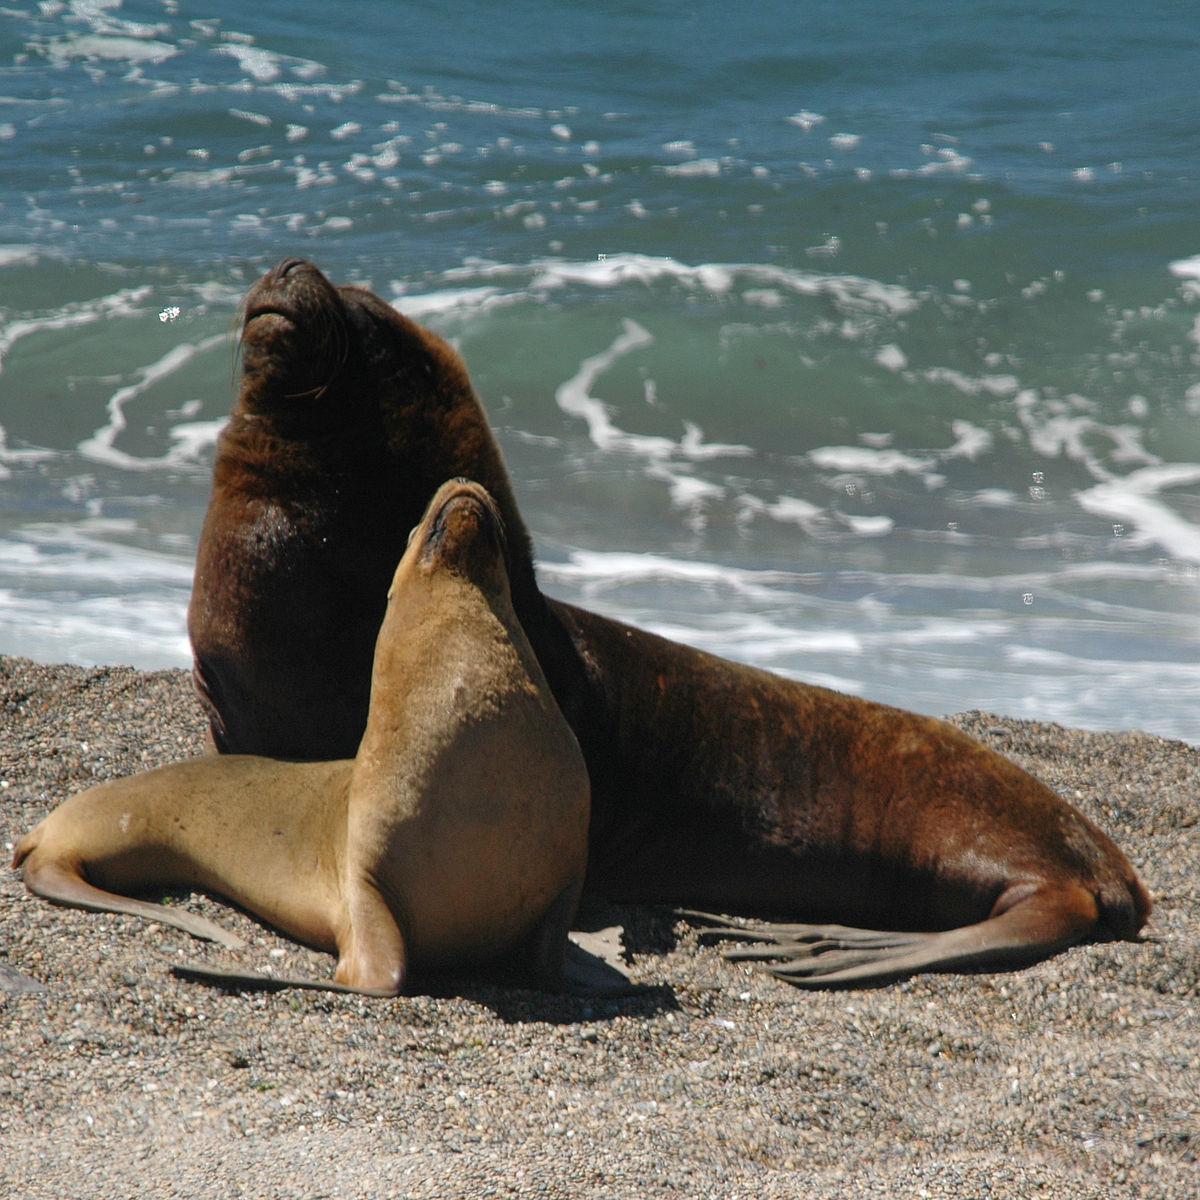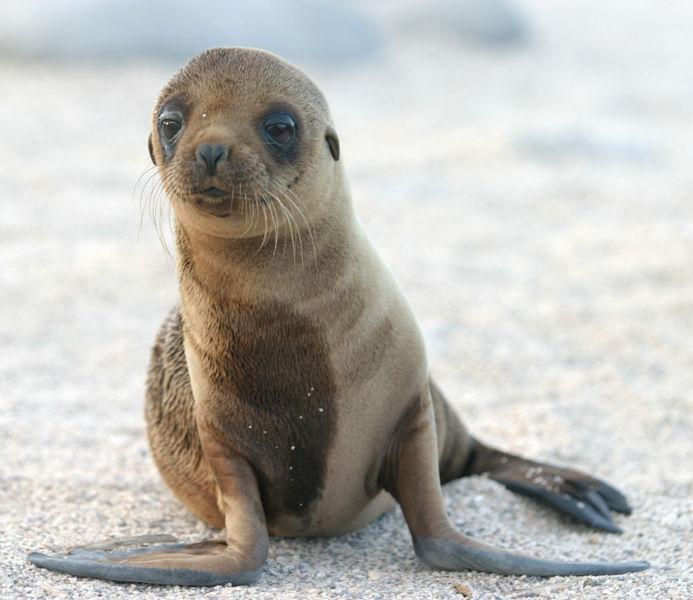The first image is the image on the left, the second image is the image on the right. Analyze the images presented: Is the assertion "The right image shows just one young seal looking forward." valid? Answer yes or no. Yes. 